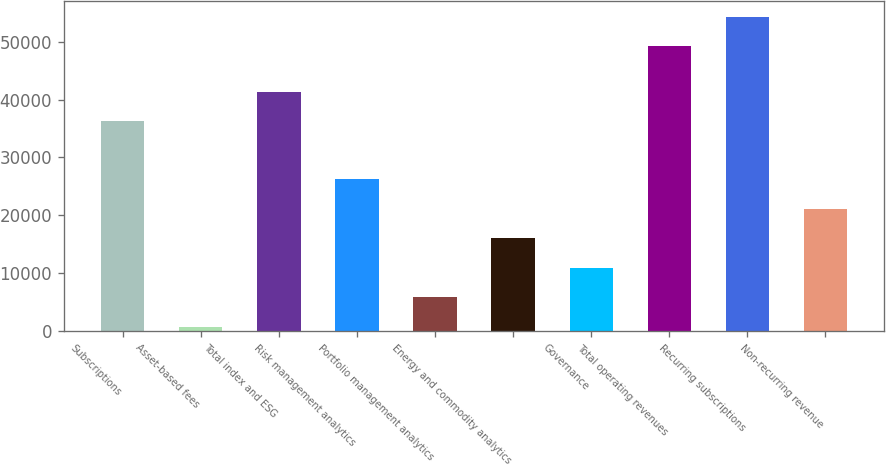<chart> <loc_0><loc_0><loc_500><loc_500><bar_chart><fcel>Subscriptions<fcel>Asset-based fees<fcel>Total index and ESG<fcel>Risk management analytics<fcel>Portfolio management analytics<fcel>Energy and commodity analytics<fcel>Governance<fcel>Total operating revenues<fcel>Recurring subscriptions<fcel>Non-recurring revenue<nl><fcel>36240<fcel>640<fcel>41361.8<fcel>26249<fcel>5761.8<fcel>16005.4<fcel>10883.6<fcel>49200<fcel>54321.8<fcel>21127.2<nl></chart> 